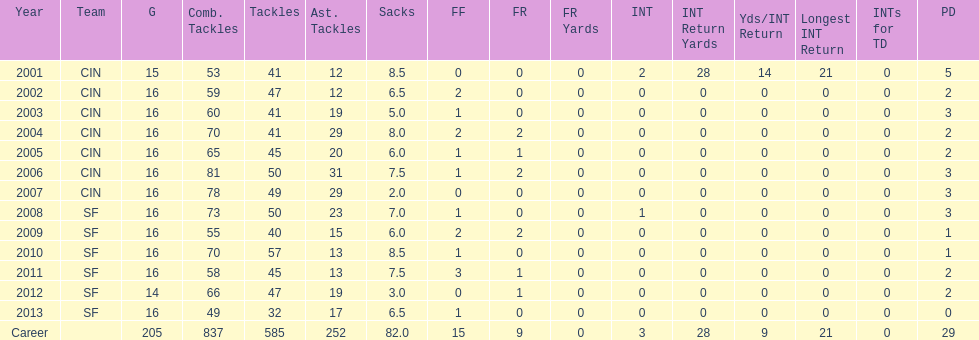How many fumble recoveries did this player have in 2004? 2. 